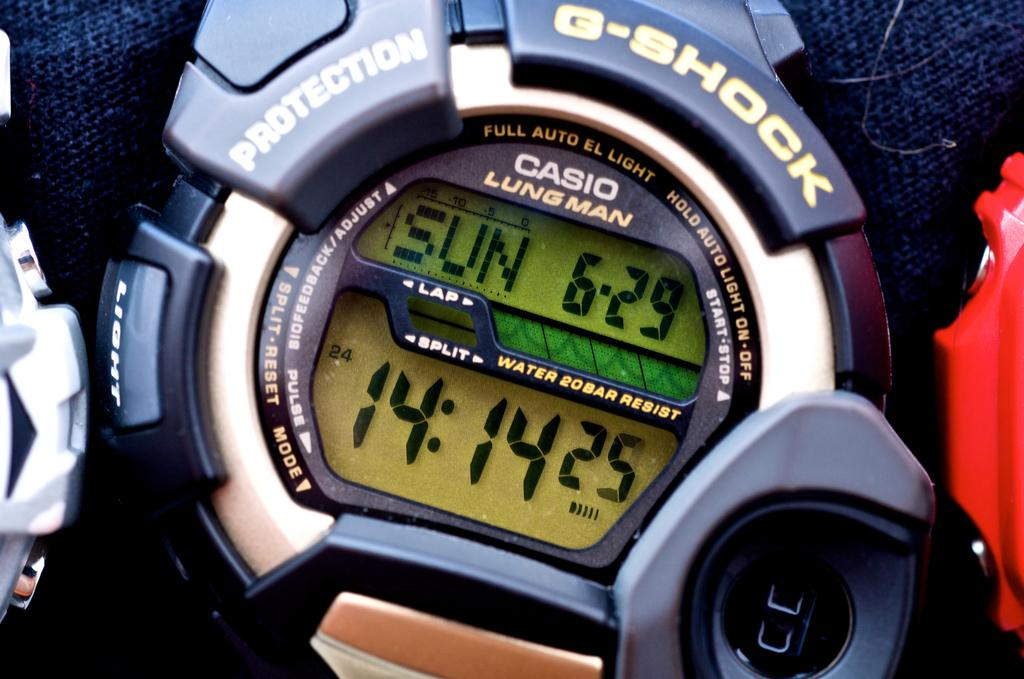<image>
Write a terse but informative summary of the picture. G-Shock watch which says CASION LUNGMAN on the top. 